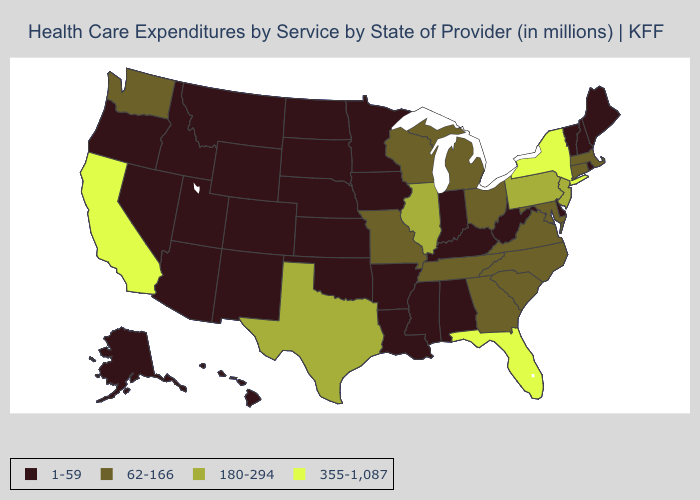Does Mississippi have a lower value than Ohio?
Answer briefly. Yes. Which states have the highest value in the USA?
Concise answer only. California, Florida, New York. What is the value of Alaska?
Short answer required. 1-59. Among the states that border Rhode Island , which have the highest value?
Be succinct. Connecticut, Massachusetts. What is the highest value in the Northeast ?
Answer briefly. 355-1,087. Does North Dakota have a lower value than New York?
Write a very short answer. Yes. What is the value of Nevada?
Quick response, please. 1-59. What is the lowest value in states that border Vermont?
Quick response, please. 1-59. What is the lowest value in the USA?
Keep it brief. 1-59. Among the states that border Minnesota , which have the lowest value?
Give a very brief answer. Iowa, North Dakota, South Dakota. What is the highest value in the USA?
Give a very brief answer. 355-1,087. Which states hav the highest value in the South?
Quick response, please. Florida. Which states have the lowest value in the USA?
Keep it brief. Alabama, Alaska, Arizona, Arkansas, Colorado, Delaware, Hawaii, Idaho, Indiana, Iowa, Kansas, Kentucky, Louisiana, Maine, Minnesota, Mississippi, Montana, Nebraska, Nevada, New Hampshire, New Mexico, North Dakota, Oklahoma, Oregon, Rhode Island, South Dakota, Utah, Vermont, West Virginia, Wyoming. Does Maryland have the lowest value in the South?
Keep it brief. No. Does North Dakota have a higher value than Oregon?
Be succinct. No. 